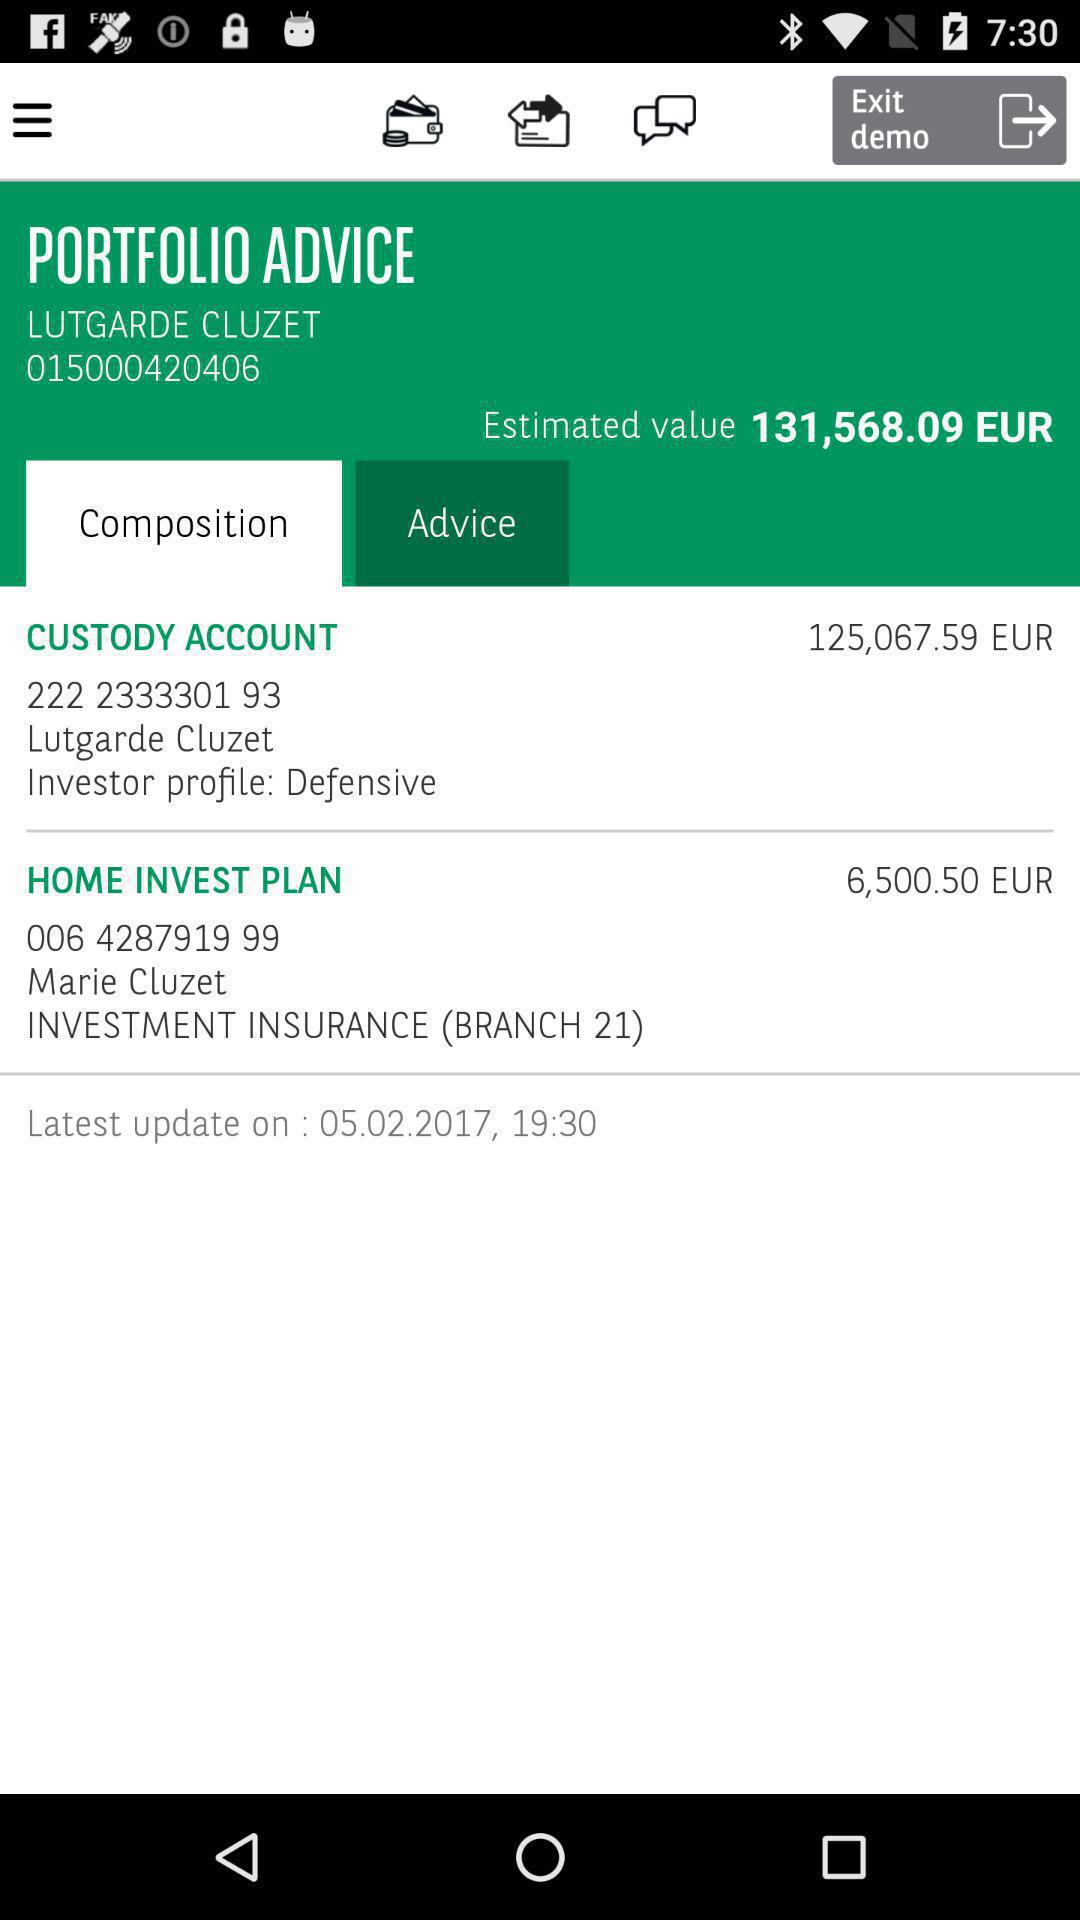What is the estimated value? The estimated value is 131,568.09 euros. 